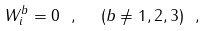Convert formula to latex. <formula><loc_0><loc_0><loc_500><loc_500>W _ { i } ^ { b } = 0 \ , \ \ ( b \ne 1 , 2 , 3 ) \ ,</formula> 